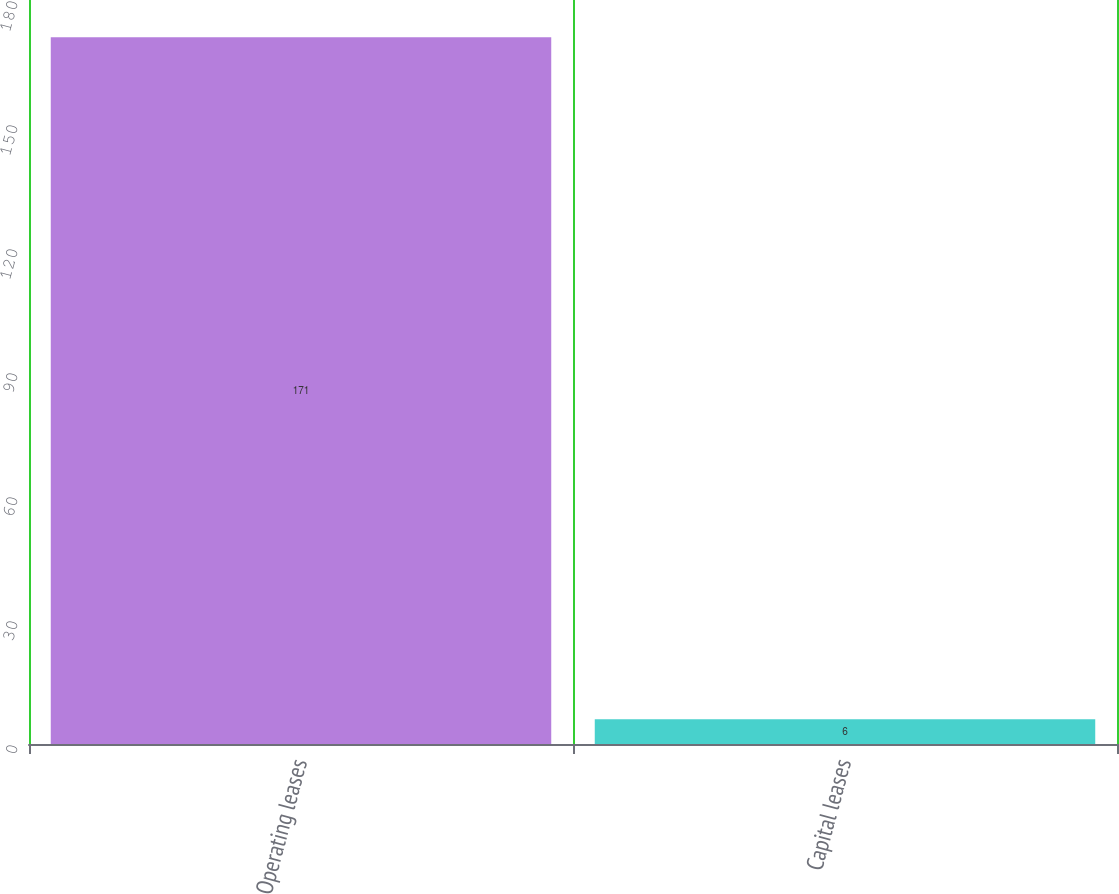Convert chart. <chart><loc_0><loc_0><loc_500><loc_500><bar_chart><fcel>Operating leases<fcel>Capital leases<nl><fcel>171<fcel>6<nl></chart> 